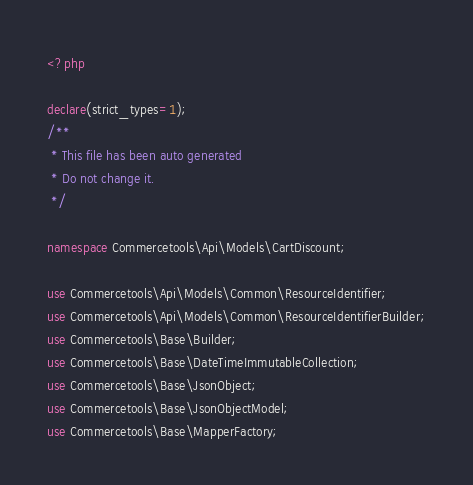Convert code to text. <code><loc_0><loc_0><loc_500><loc_500><_PHP_><?php

declare(strict_types=1);
/**
 * This file has been auto generated
 * Do not change it.
 */

namespace Commercetools\Api\Models\CartDiscount;

use Commercetools\Api\Models\Common\ResourceIdentifier;
use Commercetools\Api\Models\Common\ResourceIdentifierBuilder;
use Commercetools\Base\Builder;
use Commercetools\Base\DateTimeImmutableCollection;
use Commercetools\Base\JsonObject;
use Commercetools\Base\JsonObjectModel;
use Commercetools\Base\MapperFactory;</code> 